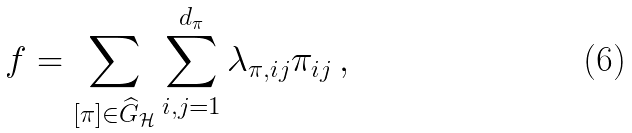Convert formula to latex. <formula><loc_0><loc_0><loc_500><loc_500>f = \sum _ { [ \pi ] \in \widehat { G } _ { \mathcal { H } } } \sum _ { i , j = 1 } ^ { d _ { \pi } } \lambda _ { \pi , i j } \pi _ { i j } \, ,</formula> 